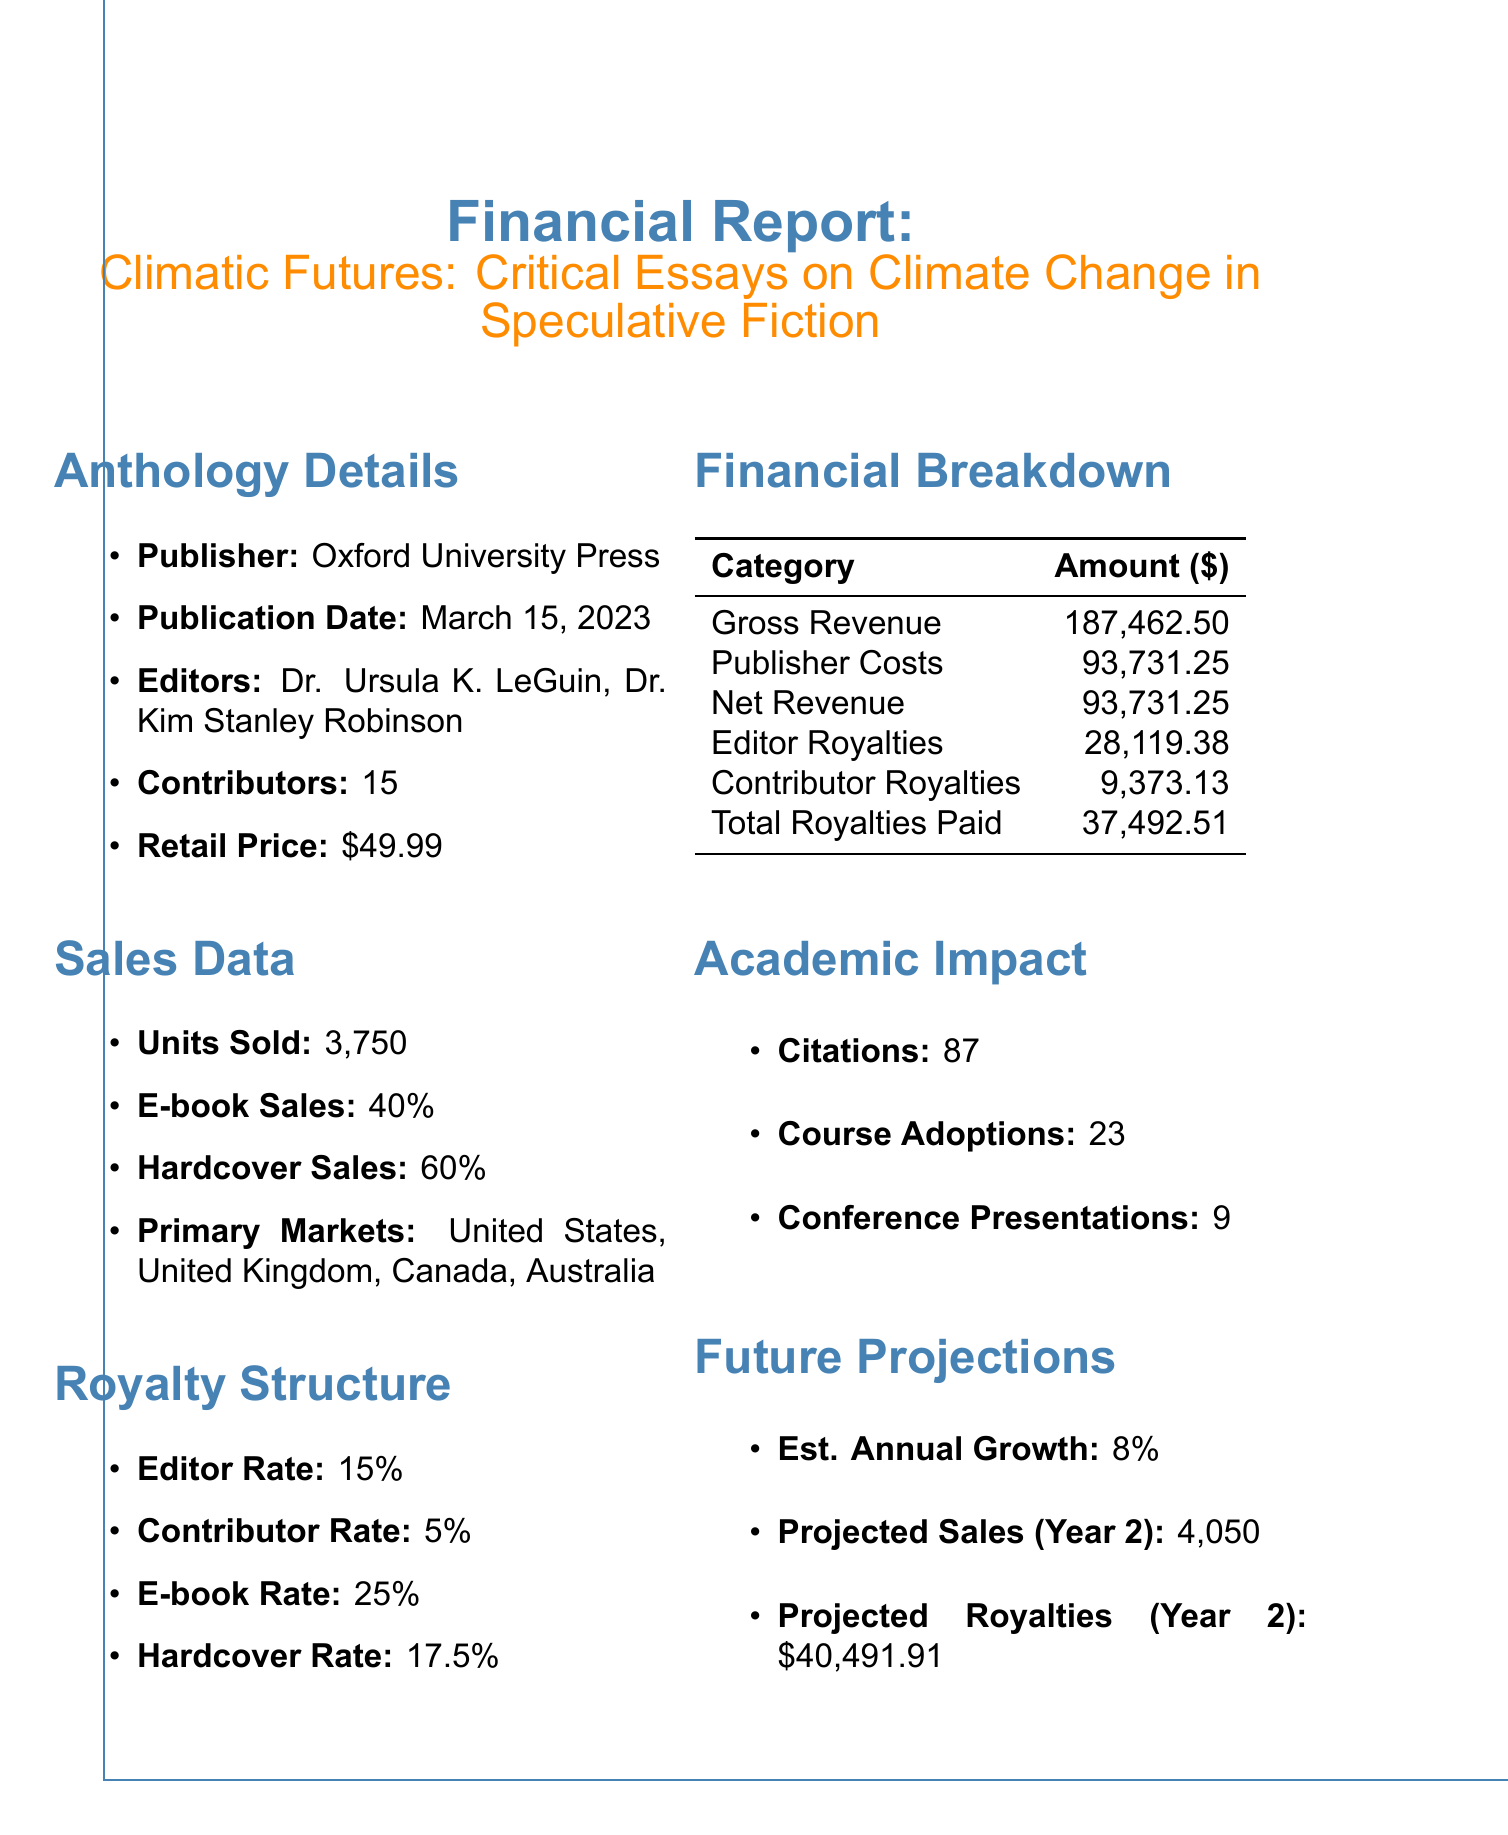What is the title of the anthology? The title of the anthology is explicitly mentioned in the document as "Climatic Futures: Critical Essays on Climate Change in Speculative Fiction."
Answer: Climatic Futures: Critical Essays on Climate Change in Speculative Fiction Who are the editors of the anthology? The editors of the anthology are named directly in the document as Dr. Ursula K. LeGuin and Dr. Kim Stanley Robinson.
Answer: Dr. Ursula K. LeGuin, Dr. Kim Stanley Robinson What is the retail price of the anthology? The document states the retail price of the anthology as $49.99.
Answer: $49.99 How many units were sold? The total number of sold units is clearly specified in the sales data of the document as 3,750.
Answer: 3,750 What percentage of sales were e-books? The document indicates that 40% of the sales were e-books.
Answer: 40% What is the total amount paid in royalties? The total royalties paid, which is part of the financial breakdown in the document, is $37,492.51.
Answer: $37,492.51 What is the estimated annual growth rate? The document lists the estimated annual growth rate as 8%.
Answer: 8% How many conference presentations are associated with the anthology? The number of conference presentations mentioned in the academic impact section of the document is 9.
Answer: 9 What is the projected number of sales in the second year? The projected sales for year 2 are identified in the document as 4,050.
Answer: 4,050 